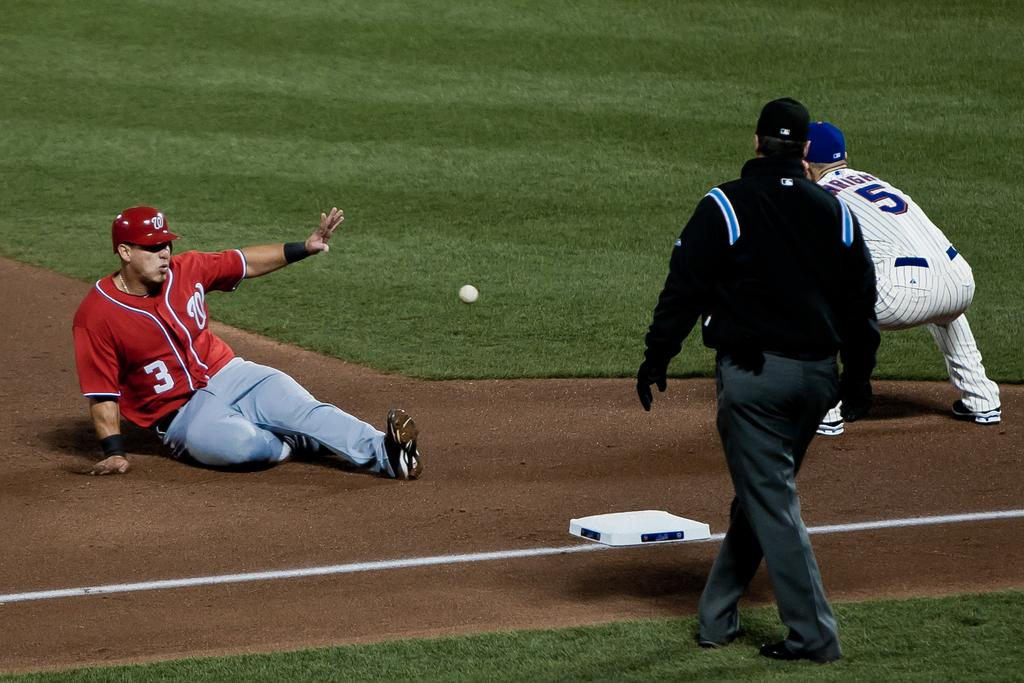<image>
Share a concise interpretation of the image provided. A man sitting on a sports field, the number 3 is on his shirt. 